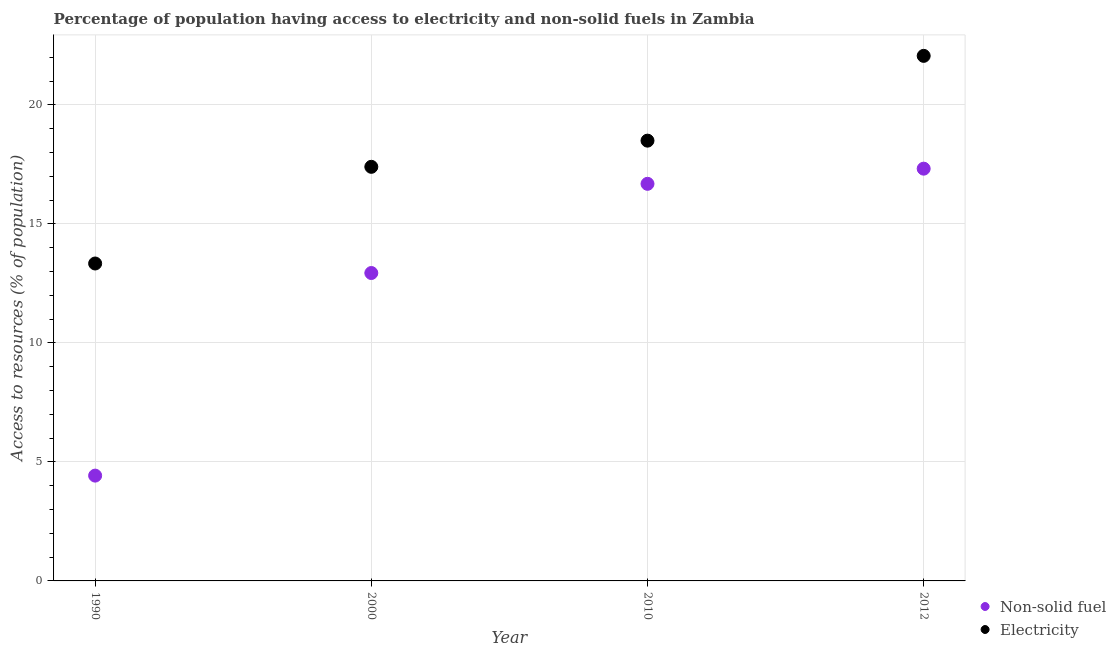Is the number of dotlines equal to the number of legend labels?
Ensure brevity in your answer.  Yes. What is the percentage of population having access to non-solid fuel in 2000?
Offer a very short reply. 12.94. Across all years, what is the maximum percentage of population having access to non-solid fuel?
Ensure brevity in your answer.  17.32. Across all years, what is the minimum percentage of population having access to electricity?
Keep it short and to the point. 13.34. In which year was the percentage of population having access to non-solid fuel minimum?
Offer a terse response. 1990. What is the total percentage of population having access to electricity in the graph?
Provide a succinct answer. 71.3. What is the difference between the percentage of population having access to electricity in 2000 and that in 2012?
Keep it short and to the point. -4.66. What is the difference between the percentage of population having access to non-solid fuel in 1990 and the percentage of population having access to electricity in 2000?
Make the answer very short. -12.98. What is the average percentage of population having access to non-solid fuel per year?
Make the answer very short. 12.84. In the year 2012, what is the difference between the percentage of population having access to electricity and percentage of population having access to non-solid fuel?
Ensure brevity in your answer.  4.74. What is the ratio of the percentage of population having access to non-solid fuel in 2010 to that in 2012?
Provide a short and direct response. 0.96. Is the percentage of population having access to non-solid fuel in 1990 less than that in 2000?
Offer a very short reply. Yes. Is the difference between the percentage of population having access to electricity in 1990 and 2010 greater than the difference between the percentage of population having access to non-solid fuel in 1990 and 2010?
Ensure brevity in your answer.  Yes. What is the difference between the highest and the second highest percentage of population having access to electricity?
Make the answer very short. 3.56. What is the difference between the highest and the lowest percentage of population having access to non-solid fuel?
Ensure brevity in your answer.  12.9. Is the sum of the percentage of population having access to electricity in 2000 and 2010 greater than the maximum percentage of population having access to non-solid fuel across all years?
Give a very brief answer. Yes. Is the percentage of population having access to non-solid fuel strictly greater than the percentage of population having access to electricity over the years?
Ensure brevity in your answer.  No. How many dotlines are there?
Keep it short and to the point. 2. What is the difference between two consecutive major ticks on the Y-axis?
Offer a very short reply. 5. Are the values on the major ticks of Y-axis written in scientific E-notation?
Your response must be concise. No. Does the graph contain any zero values?
Provide a succinct answer. No. Does the graph contain grids?
Your answer should be very brief. Yes. How are the legend labels stacked?
Your answer should be very brief. Vertical. What is the title of the graph?
Provide a succinct answer. Percentage of population having access to electricity and non-solid fuels in Zambia. Does "Canada" appear as one of the legend labels in the graph?
Your answer should be very brief. No. What is the label or title of the Y-axis?
Offer a terse response. Access to resources (% of population). What is the Access to resources (% of population) in Non-solid fuel in 1990?
Ensure brevity in your answer.  4.42. What is the Access to resources (% of population) in Electricity in 1990?
Make the answer very short. 13.34. What is the Access to resources (% of population) of Non-solid fuel in 2000?
Give a very brief answer. 12.94. What is the Access to resources (% of population) in Electricity in 2000?
Provide a short and direct response. 17.4. What is the Access to resources (% of population) in Non-solid fuel in 2010?
Offer a very short reply. 16.69. What is the Access to resources (% of population) in Non-solid fuel in 2012?
Your answer should be very brief. 17.32. What is the Access to resources (% of population) of Electricity in 2012?
Offer a terse response. 22.06. Across all years, what is the maximum Access to resources (% of population) of Non-solid fuel?
Keep it short and to the point. 17.32. Across all years, what is the maximum Access to resources (% of population) of Electricity?
Ensure brevity in your answer.  22.06. Across all years, what is the minimum Access to resources (% of population) of Non-solid fuel?
Offer a very short reply. 4.42. Across all years, what is the minimum Access to resources (% of population) of Electricity?
Provide a short and direct response. 13.34. What is the total Access to resources (% of population) in Non-solid fuel in the graph?
Offer a very short reply. 51.37. What is the total Access to resources (% of population) of Electricity in the graph?
Ensure brevity in your answer.  71.3. What is the difference between the Access to resources (% of population) of Non-solid fuel in 1990 and that in 2000?
Ensure brevity in your answer.  -8.51. What is the difference between the Access to resources (% of population) in Electricity in 1990 and that in 2000?
Ensure brevity in your answer.  -4.06. What is the difference between the Access to resources (% of population) of Non-solid fuel in 1990 and that in 2010?
Ensure brevity in your answer.  -12.26. What is the difference between the Access to resources (% of population) of Electricity in 1990 and that in 2010?
Keep it short and to the point. -5.16. What is the difference between the Access to resources (% of population) in Non-solid fuel in 1990 and that in 2012?
Offer a terse response. -12.9. What is the difference between the Access to resources (% of population) of Electricity in 1990 and that in 2012?
Give a very brief answer. -8.72. What is the difference between the Access to resources (% of population) in Non-solid fuel in 2000 and that in 2010?
Provide a short and direct response. -3.75. What is the difference between the Access to resources (% of population) in Electricity in 2000 and that in 2010?
Provide a succinct answer. -1.1. What is the difference between the Access to resources (% of population) of Non-solid fuel in 2000 and that in 2012?
Keep it short and to the point. -4.38. What is the difference between the Access to resources (% of population) in Electricity in 2000 and that in 2012?
Your response must be concise. -4.66. What is the difference between the Access to resources (% of population) of Non-solid fuel in 2010 and that in 2012?
Offer a very short reply. -0.64. What is the difference between the Access to resources (% of population) of Electricity in 2010 and that in 2012?
Give a very brief answer. -3.56. What is the difference between the Access to resources (% of population) in Non-solid fuel in 1990 and the Access to resources (% of population) in Electricity in 2000?
Keep it short and to the point. -12.97. What is the difference between the Access to resources (% of population) of Non-solid fuel in 1990 and the Access to resources (% of population) of Electricity in 2010?
Your response must be concise. -14.07. What is the difference between the Access to resources (% of population) in Non-solid fuel in 1990 and the Access to resources (% of population) in Electricity in 2012?
Offer a terse response. -17.64. What is the difference between the Access to resources (% of population) in Non-solid fuel in 2000 and the Access to resources (% of population) in Electricity in 2010?
Ensure brevity in your answer.  -5.56. What is the difference between the Access to resources (% of population) in Non-solid fuel in 2000 and the Access to resources (% of population) in Electricity in 2012?
Your answer should be compact. -9.12. What is the difference between the Access to resources (% of population) of Non-solid fuel in 2010 and the Access to resources (% of population) of Electricity in 2012?
Your answer should be compact. -5.38. What is the average Access to resources (% of population) of Non-solid fuel per year?
Offer a terse response. 12.84. What is the average Access to resources (% of population) of Electricity per year?
Provide a succinct answer. 17.83. In the year 1990, what is the difference between the Access to resources (% of population) in Non-solid fuel and Access to resources (% of population) in Electricity?
Ensure brevity in your answer.  -8.91. In the year 2000, what is the difference between the Access to resources (% of population) in Non-solid fuel and Access to resources (% of population) in Electricity?
Provide a short and direct response. -4.46. In the year 2010, what is the difference between the Access to resources (% of population) in Non-solid fuel and Access to resources (% of population) in Electricity?
Keep it short and to the point. -1.81. In the year 2012, what is the difference between the Access to resources (% of population) in Non-solid fuel and Access to resources (% of population) in Electricity?
Ensure brevity in your answer.  -4.74. What is the ratio of the Access to resources (% of population) of Non-solid fuel in 1990 to that in 2000?
Provide a succinct answer. 0.34. What is the ratio of the Access to resources (% of population) in Electricity in 1990 to that in 2000?
Offer a very short reply. 0.77. What is the ratio of the Access to resources (% of population) in Non-solid fuel in 1990 to that in 2010?
Offer a very short reply. 0.27. What is the ratio of the Access to resources (% of population) of Electricity in 1990 to that in 2010?
Offer a terse response. 0.72. What is the ratio of the Access to resources (% of population) in Non-solid fuel in 1990 to that in 2012?
Your answer should be compact. 0.26. What is the ratio of the Access to resources (% of population) in Electricity in 1990 to that in 2012?
Make the answer very short. 0.6. What is the ratio of the Access to resources (% of population) in Non-solid fuel in 2000 to that in 2010?
Provide a succinct answer. 0.78. What is the ratio of the Access to resources (% of population) of Electricity in 2000 to that in 2010?
Offer a terse response. 0.94. What is the ratio of the Access to resources (% of population) of Non-solid fuel in 2000 to that in 2012?
Ensure brevity in your answer.  0.75. What is the ratio of the Access to resources (% of population) of Electricity in 2000 to that in 2012?
Your answer should be very brief. 0.79. What is the ratio of the Access to resources (% of population) of Non-solid fuel in 2010 to that in 2012?
Provide a succinct answer. 0.96. What is the ratio of the Access to resources (% of population) of Electricity in 2010 to that in 2012?
Provide a short and direct response. 0.84. What is the difference between the highest and the second highest Access to resources (% of population) in Non-solid fuel?
Make the answer very short. 0.64. What is the difference between the highest and the second highest Access to resources (% of population) of Electricity?
Your answer should be very brief. 3.56. What is the difference between the highest and the lowest Access to resources (% of population) in Non-solid fuel?
Provide a short and direct response. 12.9. What is the difference between the highest and the lowest Access to resources (% of population) in Electricity?
Offer a terse response. 8.72. 